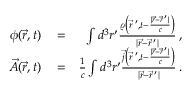<formula> <loc_0><loc_0><loc_500><loc_500>\begin{array} { r l r } { \phi ( \vec { r } , t ) } & = } & { \int d ^ { 3 } r ^ { \prime } \frac { \varrho \left ( \vec { r } \, ^ { \prime } , t - \frac { | \vec { r } - \vec { r } \, ^ { \prime } | } { c } \right ) } { | \vec { r } - \vec { r } \, ^ { \prime } | } \, , } \\ { \vec { A } ( \vec { r } , t ) } & = } & { \frac { 1 } { c } \int d ^ { 3 } r ^ { \prime } \frac { \vec { j } \left ( \vec { r } \, ^ { \prime } , t - \frac { | \vec { r } - \vec { r } \, ^ { \prime } | } { c } \right ) } { | \vec { r } - \vec { r } \, ^ { \prime } | } \, . } \end{array}</formula> 